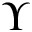Convert formula to latex. <formula><loc_0><loc_0><loc_500><loc_500>\Upsilon</formula> 